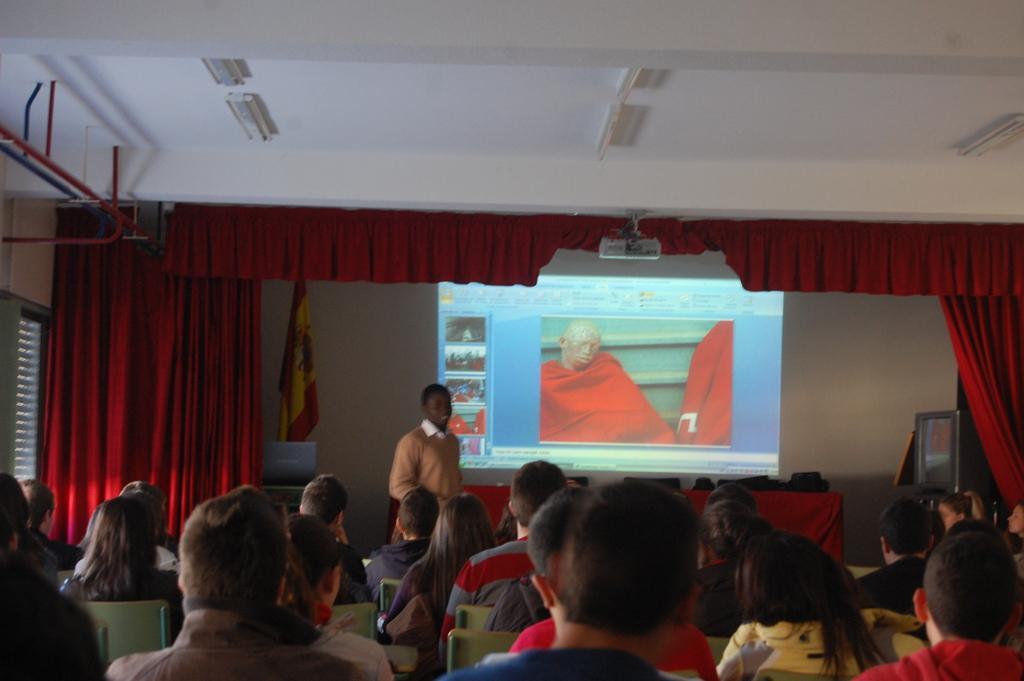Please provide a concise description of this image. In this image there are group of persons sitting on the chair, there are persons truncated towards the bottom of the image, there are persons truncated towards the right of the image, there are persons truncated towards the left of the image, there is a person standing, there is a flag, there is a laptop, there are curtains, there is a curtain truncated towards the right of the image, there is a window, there is the roof truncated towards the top of the image, there are lights on the roof, there is an object truncated towards the left of the image. 